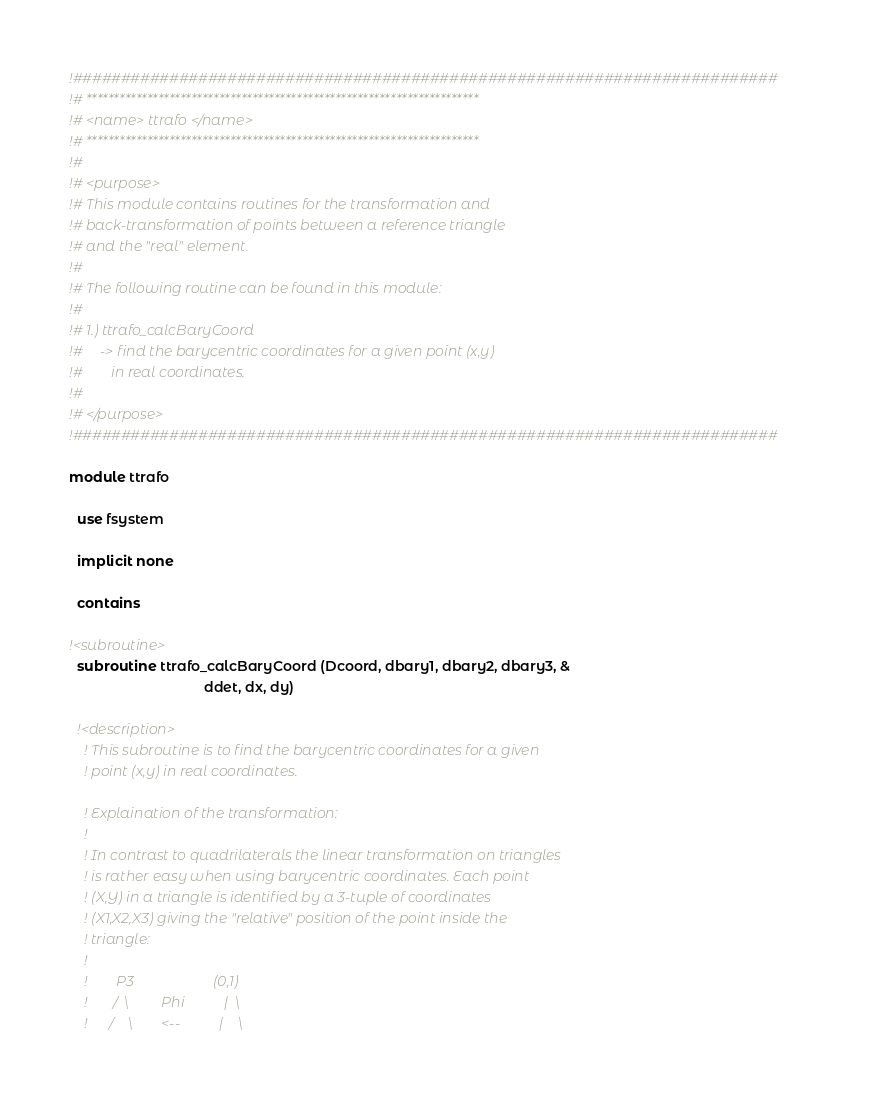<code> <loc_0><loc_0><loc_500><loc_500><_FORTRAN_>!#########################################################################
!# ***********************************************************************
!# <name> ttrafo </name>
!# ***********************************************************************
!#
!# <purpose>
!# This module contains routines for the transformation and
!# back-transformation of points between a reference triangle
!# and the "real" element.
!#
!# The following routine can be found in this module:
!#
!# 1.) ttrafo_calcBaryCoord
!#     -> find the barycentric coordinates for a given point (x,y)
!#        in real coordinates.
!#
!# </purpose>
!#########################################################################

module ttrafo

  use fsystem

  implicit none
  
  contains
  
!<subroutine>
  subroutine ttrafo_calcBaryCoord (Dcoord, dbary1, dbary2, dbary3, &
                                   ddet, dx, dy)
  
  !<description>
    ! This subroutine is to find the barycentric coordinates for a given 
    ! point (x,y) in real coordinates.
    
    ! Explaination of the transformation:
    !
    ! In contrast to quadrilaterals the linear transformation on triangles
    ! is rather easy when using barycentric coordinates. Each point
    ! (X,Y) in a triangle is identified by a 3-tuple of coordinates
    ! (X1,X2,X3) giving the "relative" position of the point inside the
    ! triangle:
    !
    !        P3                      (0,1)
    !       /  \         Phi           |  \
    !      /    \        <--           |    \</code> 